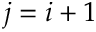<formula> <loc_0><loc_0><loc_500><loc_500>j = i + 1</formula> 